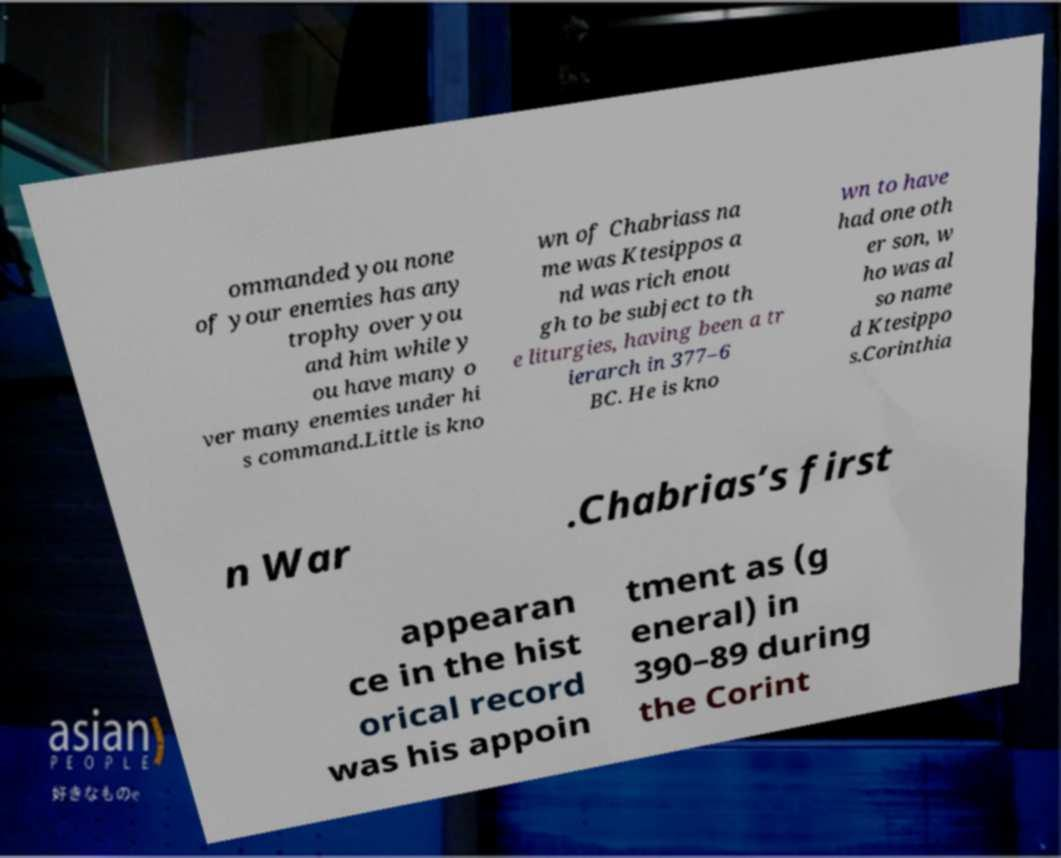Could you extract and type out the text from this image? ommanded you none of your enemies has any trophy over you and him while y ou have many o ver many enemies under hi s command.Little is kno wn of Chabriass na me was Ktesippos a nd was rich enou gh to be subject to th e liturgies, having been a tr ierarch in 377–6 BC. He is kno wn to have had one oth er son, w ho was al so name d Ktesippo s.Corinthia n War .Chabrias’s first appearan ce in the hist orical record was his appoin tment as (g eneral) in 390–89 during the Corint 